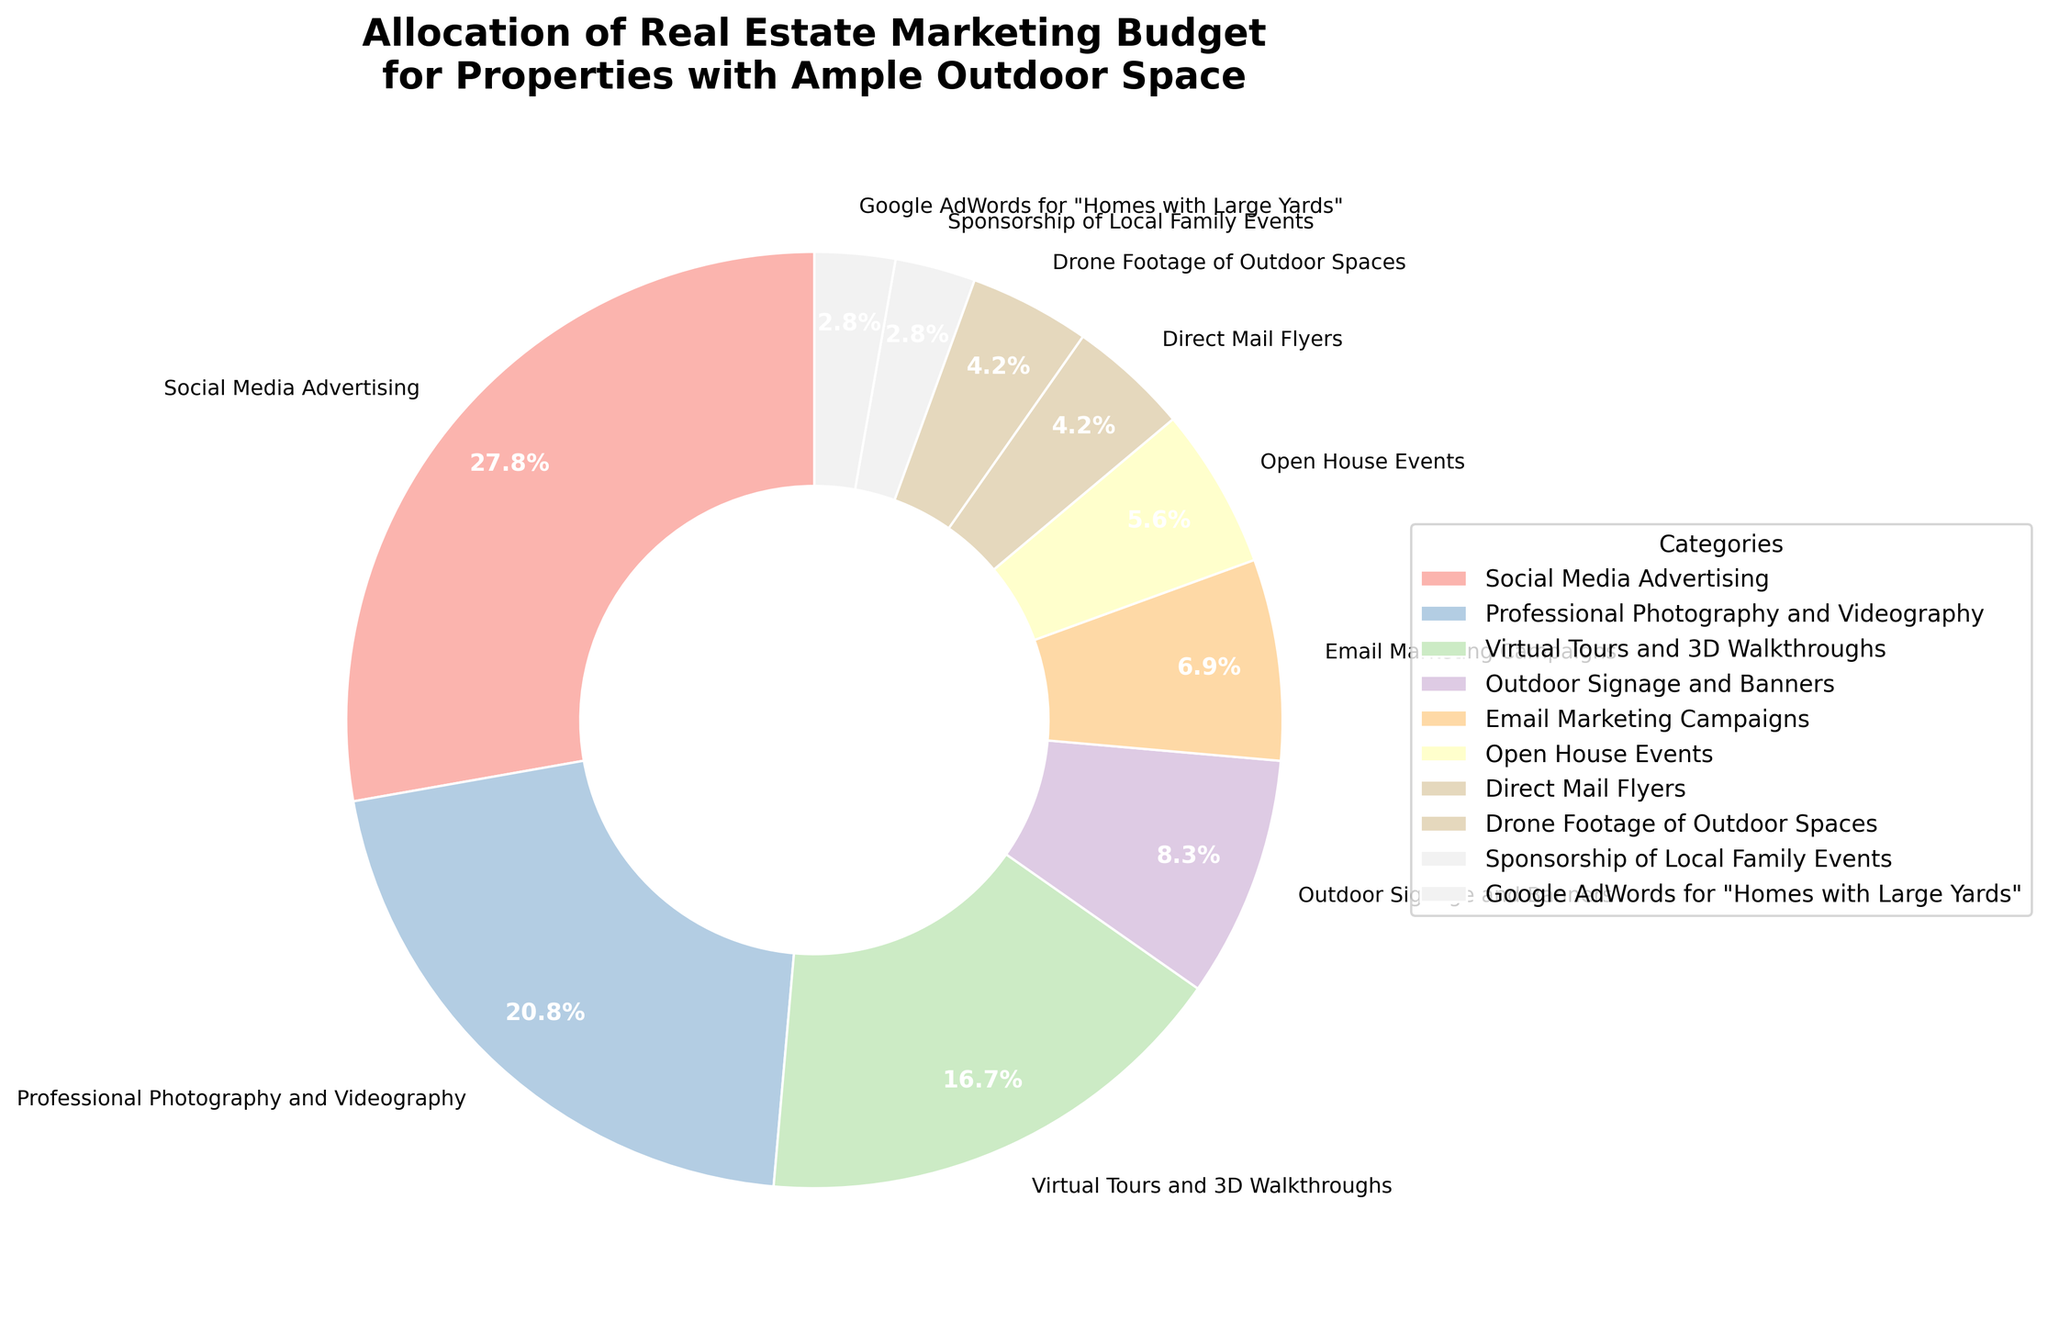What percentage of the budget is allocated to Social Media Advertising compared to Professional Photography and Videography? Social Media Advertising takes up 20% of the budget, while Professional Photography and Videography take up 15%. Simply compare 20% and 15%.
Answer: 20% vs. 15% How much more budget is allocated to Social Media Advertising than to Google AdWords for "Homes with Large Yards"? Social Media Advertising accounts for 20%, and Google AdWords for "Homes with Large Yards" accounts for 2%. Calculate the difference: 20% - 2%.
Answer: 18% What is the combined budget percentage for Virtual Tours and 3D Walkthroughs, Drone Footage of Outdoor Spaces, and Sponsorship of Local Family Events? Virtual Tours and 3D Walkthroughs are 12%, Drone Footage of Outdoor Spaces is 3%, and Sponsorship of Local Family Events is 2%. Add them together: 12% + 3% + 2%.
Answer: 17% Which category contributes the smallest percentage to the marketing budget? Among all categories, Sponsorship of Local Family Events and Google AdWords for "Homes with Large Yards" both share the smallest slice at 2%. They are the smallest percentages.
Answer: Sponsorship of Local Family Events and Google AdWords for "Homes with Large Yards" What is the total percentage for Email Marketing Campaigns, Open House Events, and Direct Mail Flyers? Email Marketing Campaigns are 5%, Open House Events are 4% and Direct Mail Flyers are 3%. Sum them: 5% + 4% + 3%.
Answer: 12% How does the budget allocation for Outdoor Signage and Banners compare to Drone Footage of Outdoor Spaces? Outdoor Signage and Banners account for 6%, while Drone Footage of Outdoor Spaces accounts for 3%. Compare them: 6% and 3%.
Answer: 6% vs. 3% What portion of the budget is allocated to Digital Marketing options (Social Media Advertising, Email Marketing Campaigns, Google AdWords)? Social Media Advertising is 20%, Email Marketing Campaigns are 5%, and Google AdWords is 2%. Add them: 20% + 5% + 2%.
Answer: 27% What is the difference in budget allocation between the highest and the lowest categories? The highest percentage is 20% for Social Media Advertising, and the lowest is 2% for Sponsorship of Local Family Events and Google AdWords for "Homes with Large Yards." Calculate the difference: 20% - 2%.
Answer: 18% 